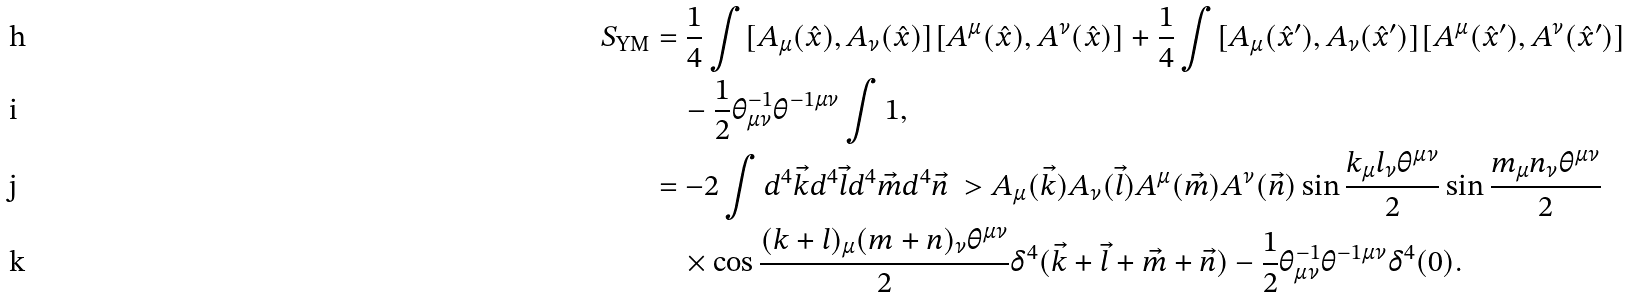Convert formula to latex. <formula><loc_0><loc_0><loc_500><loc_500>S _ { \text {YM} } & = \frac { 1 } { 4 } \int [ A _ { \mu } ( \hat { x } ) , A _ { \nu } ( \hat { x } ) ] [ A ^ { \mu } ( \hat { x } ) , A ^ { \nu } ( \hat { x } ) ] + \frac { 1 } { 4 } \int [ A _ { \mu } ( \hat { x } ^ { \prime } ) , A _ { \nu } ( \hat { x } ^ { \prime } ) ] [ A ^ { \mu } ( \hat { x } ^ { \prime } ) , A ^ { \nu } ( \hat { x } ^ { \prime } ) ] \\ & \quad - \frac { 1 } { 2 } \theta _ { \mu \nu } ^ { - 1 } \theta ^ { - 1 \mu \nu } \int 1 , \\ & = - 2 \int d ^ { 4 } \vec { k } d ^ { 4 } \vec { l } d ^ { 4 } \vec { m } d ^ { 4 } \vec { n } \ > A _ { \mu } ( \vec { k } ) A _ { \nu } ( \vec { l } ) A ^ { \mu } ( \vec { m } ) A ^ { \nu } ( \vec { n } ) \sin \frac { k _ { \mu } l _ { \nu } \theta ^ { \mu \nu } } { 2 } \sin \frac { m _ { \mu } n _ { \nu } \theta ^ { \mu \nu } } { 2 } \\ & \quad \times \cos \frac { ( k + l ) _ { \mu } ( m + n ) _ { \nu } \theta ^ { \mu \nu } } { 2 } \delta ^ { 4 } ( \vec { k } + \vec { l } + \vec { m } + \vec { n } ) - \frac { 1 } { 2 } \theta _ { \mu \nu } ^ { - 1 } \theta ^ { - 1 \mu \nu } \delta ^ { 4 } ( 0 ) .</formula> 